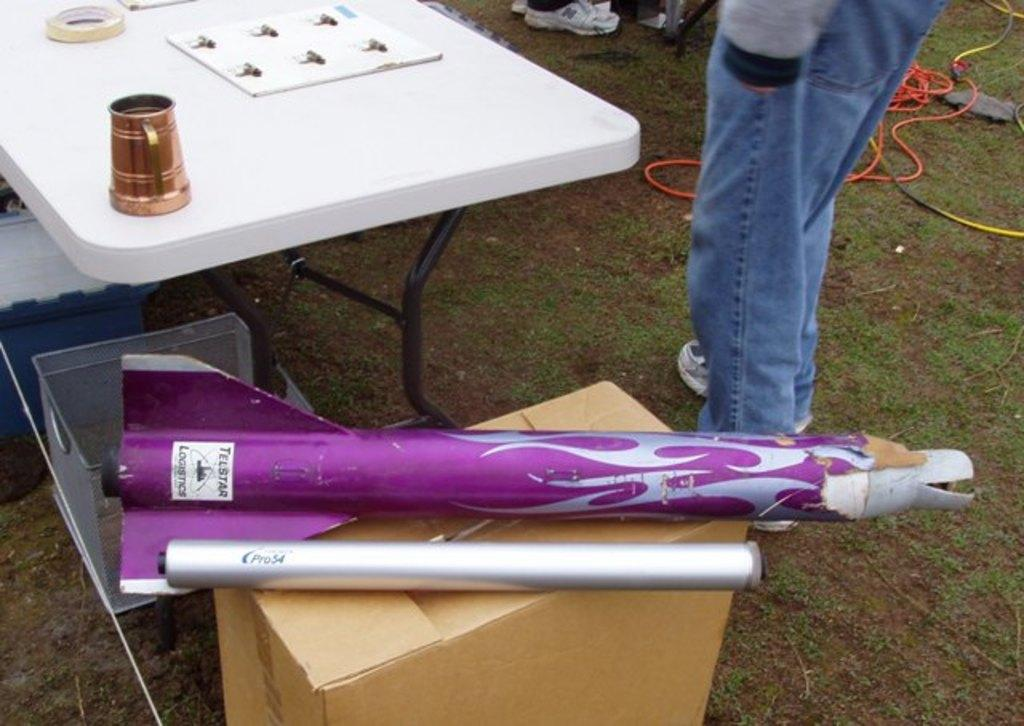What is the main subject of the image? There is a person standing in the image. What object can be seen near the person? There is a table in the image. What is on the table? There is a glass and cello tape on the table. Can you tell me how many airplanes are visible in the image? There are no airplanes present in the image. What type of authority figure is standing near the table? There is no authority figure mentioned or visible in the image. 